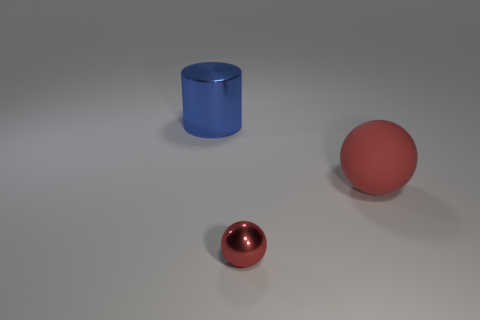Is there any other thing that is the same size as the red shiny thing?
Make the answer very short. No. What is the material of the large object that is the same shape as the tiny red thing?
Provide a succinct answer. Rubber. Are there any other things that are the same material as the big cylinder?
Your answer should be very brief. Yes. How many spheres are big shiny things or small red metallic objects?
Make the answer very short. 1. There is a shiny object that is in front of the large metal cylinder; is its size the same as the blue shiny object that is on the left side of the small red ball?
Ensure brevity in your answer.  No. There is a large object on the right side of the shiny thing in front of the large cylinder; what is it made of?
Provide a short and direct response. Rubber. Is the number of blue shiny cylinders that are in front of the metal sphere less than the number of big balls?
Make the answer very short. Yes. What shape is the other object that is the same material as the blue object?
Keep it short and to the point. Sphere. How many other objects are the same shape as the tiny metal thing?
Offer a terse response. 1. What number of purple objects are either small things or large rubber things?
Offer a terse response. 0. 